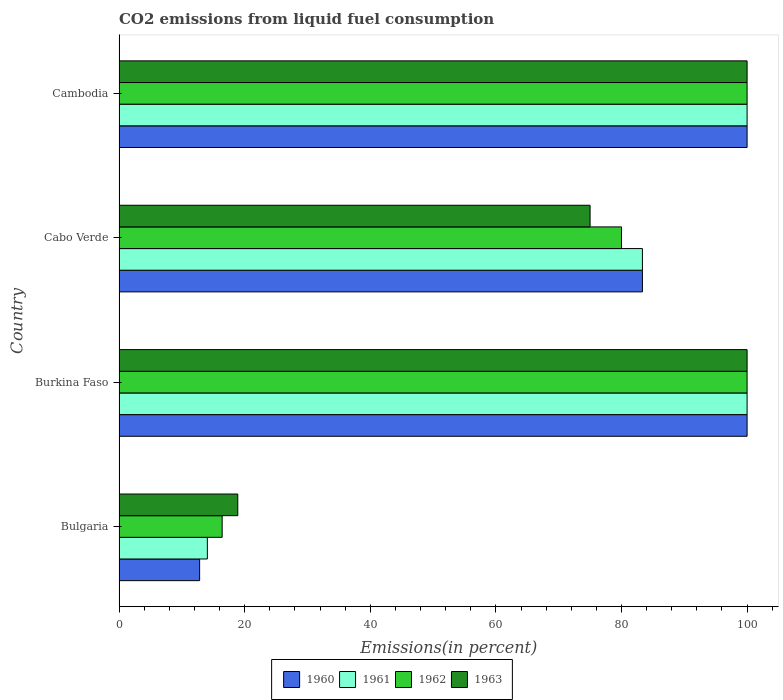How many different coloured bars are there?
Your answer should be very brief. 4. How many groups of bars are there?
Your response must be concise. 4. Are the number of bars per tick equal to the number of legend labels?
Offer a terse response. Yes. How many bars are there on the 4th tick from the top?
Keep it short and to the point. 4. How many bars are there on the 1st tick from the bottom?
Keep it short and to the point. 4. What is the label of the 2nd group of bars from the top?
Your answer should be very brief. Cabo Verde. What is the total CO2 emitted in 1963 in Bulgaria?
Make the answer very short. 18.9. Across all countries, what is the maximum total CO2 emitted in 1962?
Offer a very short reply. 100. Across all countries, what is the minimum total CO2 emitted in 1961?
Your response must be concise. 14.06. In which country was the total CO2 emitted in 1960 maximum?
Make the answer very short. Burkina Faso. What is the total total CO2 emitted in 1960 in the graph?
Provide a short and direct response. 296.16. What is the difference between the total CO2 emitted in 1960 in Bulgaria and that in Burkina Faso?
Offer a very short reply. -87.17. What is the difference between the total CO2 emitted in 1960 in Cambodia and the total CO2 emitted in 1963 in Bulgaria?
Offer a very short reply. 81.1. What is the average total CO2 emitted in 1960 per country?
Offer a very short reply. 74.04. What is the difference between the total CO2 emitted in 1962 and total CO2 emitted in 1960 in Cabo Verde?
Offer a very short reply. -3.33. Is the total CO2 emitted in 1963 in Burkina Faso less than that in Cambodia?
Offer a very short reply. No. What is the difference between the highest and the second highest total CO2 emitted in 1961?
Your answer should be very brief. 0. What is the difference between the highest and the lowest total CO2 emitted in 1961?
Offer a terse response. 85.94. Is the sum of the total CO2 emitted in 1962 in Bulgaria and Cambodia greater than the maximum total CO2 emitted in 1961 across all countries?
Offer a very short reply. Yes. What does the 4th bar from the top in Cabo Verde represents?
Your answer should be very brief. 1960. What does the 1st bar from the bottom in Bulgaria represents?
Keep it short and to the point. 1960. How many bars are there?
Provide a short and direct response. 16. Are all the bars in the graph horizontal?
Your answer should be very brief. Yes. How many countries are there in the graph?
Your answer should be compact. 4. What is the difference between two consecutive major ticks on the X-axis?
Your answer should be very brief. 20. Are the values on the major ticks of X-axis written in scientific E-notation?
Provide a succinct answer. No. Does the graph contain any zero values?
Provide a succinct answer. No. Does the graph contain grids?
Give a very brief answer. No. Where does the legend appear in the graph?
Provide a succinct answer. Bottom center. How are the legend labels stacked?
Provide a short and direct response. Horizontal. What is the title of the graph?
Make the answer very short. CO2 emissions from liquid fuel consumption. Does "1975" appear as one of the legend labels in the graph?
Give a very brief answer. No. What is the label or title of the X-axis?
Keep it short and to the point. Emissions(in percent). What is the Emissions(in percent) in 1960 in Bulgaria?
Your response must be concise. 12.83. What is the Emissions(in percent) of 1961 in Bulgaria?
Make the answer very short. 14.06. What is the Emissions(in percent) in 1962 in Bulgaria?
Offer a very short reply. 16.42. What is the Emissions(in percent) in 1963 in Bulgaria?
Offer a terse response. 18.9. What is the Emissions(in percent) of 1962 in Burkina Faso?
Provide a succinct answer. 100. What is the Emissions(in percent) in 1963 in Burkina Faso?
Your answer should be compact. 100. What is the Emissions(in percent) in 1960 in Cabo Verde?
Your response must be concise. 83.33. What is the Emissions(in percent) in 1961 in Cabo Verde?
Make the answer very short. 83.33. What is the Emissions(in percent) of 1963 in Cabo Verde?
Provide a succinct answer. 75. What is the Emissions(in percent) of 1960 in Cambodia?
Give a very brief answer. 100. What is the Emissions(in percent) of 1962 in Cambodia?
Offer a very short reply. 100. Across all countries, what is the maximum Emissions(in percent) of 1962?
Keep it short and to the point. 100. Across all countries, what is the maximum Emissions(in percent) in 1963?
Keep it short and to the point. 100. Across all countries, what is the minimum Emissions(in percent) of 1960?
Your response must be concise. 12.83. Across all countries, what is the minimum Emissions(in percent) in 1961?
Offer a terse response. 14.06. Across all countries, what is the minimum Emissions(in percent) of 1962?
Your answer should be very brief. 16.42. Across all countries, what is the minimum Emissions(in percent) of 1963?
Keep it short and to the point. 18.9. What is the total Emissions(in percent) in 1960 in the graph?
Your answer should be very brief. 296.16. What is the total Emissions(in percent) in 1961 in the graph?
Your answer should be compact. 297.4. What is the total Emissions(in percent) in 1962 in the graph?
Ensure brevity in your answer.  296.42. What is the total Emissions(in percent) of 1963 in the graph?
Your answer should be compact. 293.9. What is the difference between the Emissions(in percent) of 1960 in Bulgaria and that in Burkina Faso?
Your answer should be compact. -87.17. What is the difference between the Emissions(in percent) in 1961 in Bulgaria and that in Burkina Faso?
Provide a short and direct response. -85.94. What is the difference between the Emissions(in percent) in 1962 in Bulgaria and that in Burkina Faso?
Your answer should be very brief. -83.58. What is the difference between the Emissions(in percent) in 1963 in Bulgaria and that in Burkina Faso?
Your response must be concise. -81.1. What is the difference between the Emissions(in percent) in 1960 in Bulgaria and that in Cabo Verde?
Your answer should be compact. -70.5. What is the difference between the Emissions(in percent) of 1961 in Bulgaria and that in Cabo Verde?
Provide a short and direct response. -69.27. What is the difference between the Emissions(in percent) in 1962 in Bulgaria and that in Cabo Verde?
Your answer should be compact. -63.58. What is the difference between the Emissions(in percent) of 1963 in Bulgaria and that in Cabo Verde?
Offer a very short reply. -56.1. What is the difference between the Emissions(in percent) in 1960 in Bulgaria and that in Cambodia?
Your answer should be compact. -87.17. What is the difference between the Emissions(in percent) of 1961 in Bulgaria and that in Cambodia?
Offer a very short reply. -85.94. What is the difference between the Emissions(in percent) in 1962 in Bulgaria and that in Cambodia?
Give a very brief answer. -83.58. What is the difference between the Emissions(in percent) in 1963 in Bulgaria and that in Cambodia?
Provide a short and direct response. -81.1. What is the difference between the Emissions(in percent) of 1960 in Burkina Faso and that in Cabo Verde?
Your answer should be compact. 16.67. What is the difference between the Emissions(in percent) in 1961 in Burkina Faso and that in Cabo Verde?
Ensure brevity in your answer.  16.67. What is the difference between the Emissions(in percent) of 1960 in Cabo Verde and that in Cambodia?
Give a very brief answer. -16.67. What is the difference between the Emissions(in percent) of 1961 in Cabo Verde and that in Cambodia?
Offer a terse response. -16.67. What is the difference between the Emissions(in percent) in 1963 in Cabo Verde and that in Cambodia?
Offer a terse response. -25. What is the difference between the Emissions(in percent) in 1960 in Bulgaria and the Emissions(in percent) in 1961 in Burkina Faso?
Provide a succinct answer. -87.17. What is the difference between the Emissions(in percent) in 1960 in Bulgaria and the Emissions(in percent) in 1962 in Burkina Faso?
Keep it short and to the point. -87.17. What is the difference between the Emissions(in percent) of 1960 in Bulgaria and the Emissions(in percent) of 1963 in Burkina Faso?
Offer a terse response. -87.17. What is the difference between the Emissions(in percent) of 1961 in Bulgaria and the Emissions(in percent) of 1962 in Burkina Faso?
Offer a terse response. -85.94. What is the difference between the Emissions(in percent) of 1961 in Bulgaria and the Emissions(in percent) of 1963 in Burkina Faso?
Provide a short and direct response. -85.94. What is the difference between the Emissions(in percent) of 1962 in Bulgaria and the Emissions(in percent) of 1963 in Burkina Faso?
Provide a succinct answer. -83.58. What is the difference between the Emissions(in percent) of 1960 in Bulgaria and the Emissions(in percent) of 1961 in Cabo Verde?
Provide a succinct answer. -70.5. What is the difference between the Emissions(in percent) of 1960 in Bulgaria and the Emissions(in percent) of 1962 in Cabo Verde?
Offer a very short reply. -67.17. What is the difference between the Emissions(in percent) of 1960 in Bulgaria and the Emissions(in percent) of 1963 in Cabo Verde?
Your response must be concise. -62.17. What is the difference between the Emissions(in percent) of 1961 in Bulgaria and the Emissions(in percent) of 1962 in Cabo Verde?
Keep it short and to the point. -65.94. What is the difference between the Emissions(in percent) of 1961 in Bulgaria and the Emissions(in percent) of 1963 in Cabo Verde?
Offer a terse response. -60.94. What is the difference between the Emissions(in percent) of 1962 in Bulgaria and the Emissions(in percent) of 1963 in Cabo Verde?
Your answer should be compact. -58.58. What is the difference between the Emissions(in percent) of 1960 in Bulgaria and the Emissions(in percent) of 1961 in Cambodia?
Give a very brief answer. -87.17. What is the difference between the Emissions(in percent) of 1960 in Bulgaria and the Emissions(in percent) of 1962 in Cambodia?
Make the answer very short. -87.17. What is the difference between the Emissions(in percent) of 1960 in Bulgaria and the Emissions(in percent) of 1963 in Cambodia?
Offer a very short reply. -87.17. What is the difference between the Emissions(in percent) in 1961 in Bulgaria and the Emissions(in percent) in 1962 in Cambodia?
Keep it short and to the point. -85.94. What is the difference between the Emissions(in percent) in 1961 in Bulgaria and the Emissions(in percent) in 1963 in Cambodia?
Your answer should be very brief. -85.94. What is the difference between the Emissions(in percent) of 1962 in Bulgaria and the Emissions(in percent) of 1963 in Cambodia?
Provide a short and direct response. -83.58. What is the difference between the Emissions(in percent) of 1960 in Burkina Faso and the Emissions(in percent) of 1961 in Cabo Verde?
Ensure brevity in your answer.  16.67. What is the difference between the Emissions(in percent) in 1961 in Burkina Faso and the Emissions(in percent) in 1963 in Cabo Verde?
Keep it short and to the point. 25. What is the difference between the Emissions(in percent) of 1960 in Burkina Faso and the Emissions(in percent) of 1961 in Cambodia?
Provide a short and direct response. 0. What is the difference between the Emissions(in percent) in 1960 in Burkina Faso and the Emissions(in percent) in 1962 in Cambodia?
Your answer should be very brief. 0. What is the difference between the Emissions(in percent) of 1960 in Burkina Faso and the Emissions(in percent) of 1963 in Cambodia?
Provide a succinct answer. 0. What is the difference between the Emissions(in percent) of 1961 in Burkina Faso and the Emissions(in percent) of 1962 in Cambodia?
Ensure brevity in your answer.  0. What is the difference between the Emissions(in percent) in 1961 in Burkina Faso and the Emissions(in percent) in 1963 in Cambodia?
Ensure brevity in your answer.  0. What is the difference between the Emissions(in percent) in 1960 in Cabo Verde and the Emissions(in percent) in 1961 in Cambodia?
Make the answer very short. -16.67. What is the difference between the Emissions(in percent) of 1960 in Cabo Verde and the Emissions(in percent) of 1962 in Cambodia?
Your response must be concise. -16.67. What is the difference between the Emissions(in percent) in 1960 in Cabo Verde and the Emissions(in percent) in 1963 in Cambodia?
Ensure brevity in your answer.  -16.67. What is the difference between the Emissions(in percent) of 1961 in Cabo Verde and the Emissions(in percent) of 1962 in Cambodia?
Provide a short and direct response. -16.67. What is the difference between the Emissions(in percent) of 1961 in Cabo Verde and the Emissions(in percent) of 1963 in Cambodia?
Your answer should be very brief. -16.67. What is the average Emissions(in percent) of 1960 per country?
Give a very brief answer. 74.04. What is the average Emissions(in percent) of 1961 per country?
Provide a succinct answer. 74.35. What is the average Emissions(in percent) of 1962 per country?
Keep it short and to the point. 74.1. What is the average Emissions(in percent) in 1963 per country?
Offer a very short reply. 73.48. What is the difference between the Emissions(in percent) of 1960 and Emissions(in percent) of 1961 in Bulgaria?
Your response must be concise. -1.23. What is the difference between the Emissions(in percent) of 1960 and Emissions(in percent) of 1962 in Bulgaria?
Offer a terse response. -3.59. What is the difference between the Emissions(in percent) in 1960 and Emissions(in percent) in 1963 in Bulgaria?
Keep it short and to the point. -6.08. What is the difference between the Emissions(in percent) in 1961 and Emissions(in percent) in 1962 in Bulgaria?
Provide a succinct answer. -2.35. What is the difference between the Emissions(in percent) of 1961 and Emissions(in percent) of 1963 in Bulgaria?
Provide a short and direct response. -4.84. What is the difference between the Emissions(in percent) of 1962 and Emissions(in percent) of 1963 in Bulgaria?
Offer a very short reply. -2.49. What is the difference between the Emissions(in percent) of 1960 and Emissions(in percent) of 1961 in Burkina Faso?
Your answer should be very brief. 0. What is the difference between the Emissions(in percent) in 1961 and Emissions(in percent) in 1962 in Burkina Faso?
Your answer should be compact. 0. What is the difference between the Emissions(in percent) in 1961 and Emissions(in percent) in 1963 in Burkina Faso?
Provide a succinct answer. 0. What is the difference between the Emissions(in percent) of 1960 and Emissions(in percent) of 1961 in Cabo Verde?
Offer a very short reply. 0. What is the difference between the Emissions(in percent) of 1960 and Emissions(in percent) of 1963 in Cabo Verde?
Your answer should be compact. 8.33. What is the difference between the Emissions(in percent) of 1961 and Emissions(in percent) of 1963 in Cabo Verde?
Your answer should be very brief. 8.33. What is the difference between the Emissions(in percent) of 1962 and Emissions(in percent) of 1963 in Cabo Verde?
Provide a succinct answer. 5. What is the difference between the Emissions(in percent) in 1960 and Emissions(in percent) in 1961 in Cambodia?
Your answer should be compact. 0. What is the difference between the Emissions(in percent) of 1960 and Emissions(in percent) of 1963 in Cambodia?
Your answer should be compact. 0. What is the difference between the Emissions(in percent) of 1961 and Emissions(in percent) of 1963 in Cambodia?
Offer a terse response. 0. What is the ratio of the Emissions(in percent) in 1960 in Bulgaria to that in Burkina Faso?
Your response must be concise. 0.13. What is the ratio of the Emissions(in percent) of 1961 in Bulgaria to that in Burkina Faso?
Provide a short and direct response. 0.14. What is the ratio of the Emissions(in percent) of 1962 in Bulgaria to that in Burkina Faso?
Give a very brief answer. 0.16. What is the ratio of the Emissions(in percent) in 1963 in Bulgaria to that in Burkina Faso?
Give a very brief answer. 0.19. What is the ratio of the Emissions(in percent) of 1960 in Bulgaria to that in Cabo Verde?
Your answer should be compact. 0.15. What is the ratio of the Emissions(in percent) in 1961 in Bulgaria to that in Cabo Verde?
Provide a succinct answer. 0.17. What is the ratio of the Emissions(in percent) in 1962 in Bulgaria to that in Cabo Verde?
Keep it short and to the point. 0.21. What is the ratio of the Emissions(in percent) of 1963 in Bulgaria to that in Cabo Verde?
Make the answer very short. 0.25. What is the ratio of the Emissions(in percent) in 1960 in Bulgaria to that in Cambodia?
Your answer should be compact. 0.13. What is the ratio of the Emissions(in percent) of 1961 in Bulgaria to that in Cambodia?
Keep it short and to the point. 0.14. What is the ratio of the Emissions(in percent) in 1962 in Bulgaria to that in Cambodia?
Provide a short and direct response. 0.16. What is the ratio of the Emissions(in percent) in 1963 in Bulgaria to that in Cambodia?
Provide a succinct answer. 0.19. What is the ratio of the Emissions(in percent) in 1960 in Burkina Faso to that in Cabo Verde?
Provide a succinct answer. 1.2. What is the ratio of the Emissions(in percent) in 1962 in Burkina Faso to that in Cabo Verde?
Your answer should be very brief. 1.25. What is the ratio of the Emissions(in percent) of 1963 in Burkina Faso to that in Cabo Verde?
Your answer should be compact. 1.33. What is the ratio of the Emissions(in percent) of 1960 in Burkina Faso to that in Cambodia?
Provide a short and direct response. 1. What is the ratio of the Emissions(in percent) of 1963 in Burkina Faso to that in Cambodia?
Make the answer very short. 1. What is the ratio of the Emissions(in percent) in 1963 in Cabo Verde to that in Cambodia?
Offer a terse response. 0.75. What is the difference between the highest and the second highest Emissions(in percent) of 1961?
Your answer should be compact. 0. What is the difference between the highest and the second highest Emissions(in percent) in 1962?
Make the answer very short. 0. What is the difference between the highest and the lowest Emissions(in percent) in 1960?
Give a very brief answer. 87.17. What is the difference between the highest and the lowest Emissions(in percent) in 1961?
Offer a very short reply. 85.94. What is the difference between the highest and the lowest Emissions(in percent) of 1962?
Keep it short and to the point. 83.58. What is the difference between the highest and the lowest Emissions(in percent) of 1963?
Your response must be concise. 81.1. 